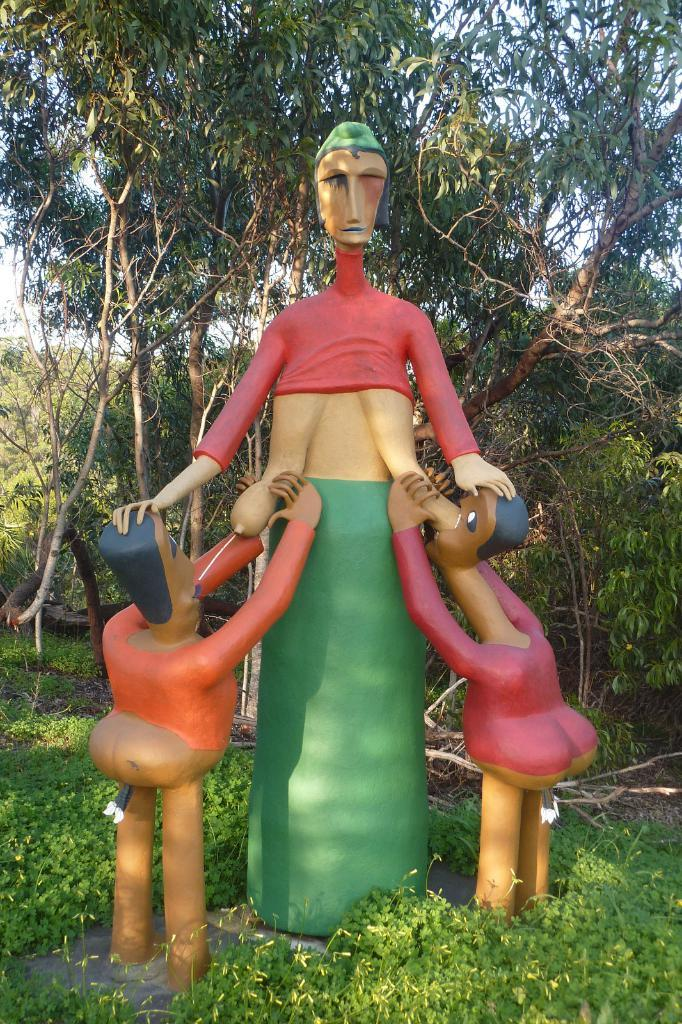What can be seen in the foreground of the image? There are statues in the foreground of the image. What is visible in the background of the image? There are trees in the background of the image. What type of vegetation is present at the bottom of the image? There are plants at the bottom of the image. What type of pizzas are being served in the image? There are no pizzas present in the image; it features statues, trees, and plants. What is the value of the plants in the image? The value of the plants cannot be determined from the image alone, as it depends on factors such as rarity, size, and condition. 